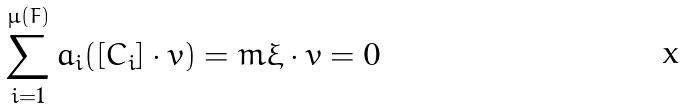<formula> <loc_0><loc_0><loc_500><loc_500>\sum _ { i = 1 } ^ { \mu ( F ) } a _ { i } ( [ C _ { i } ] \cdot v ) = m \xi \cdot v = 0</formula> 